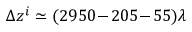Convert formula to latex. <formula><loc_0><loc_0><loc_500><loc_500>\Delta z ^ { i } \simeq ( 2 9 5 0 \, - \, 2 0 5 \, - \, 5 5 ) \lambda</formula> 